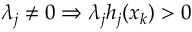Convert formula to latex. <formula><loc_0><loc_0><loc_500><loc_500>\lambda _ { j } \neq 0 \Rightarrow \lambda _ { j } h _ { j } ( x _ { k } ) > 0</formula> 